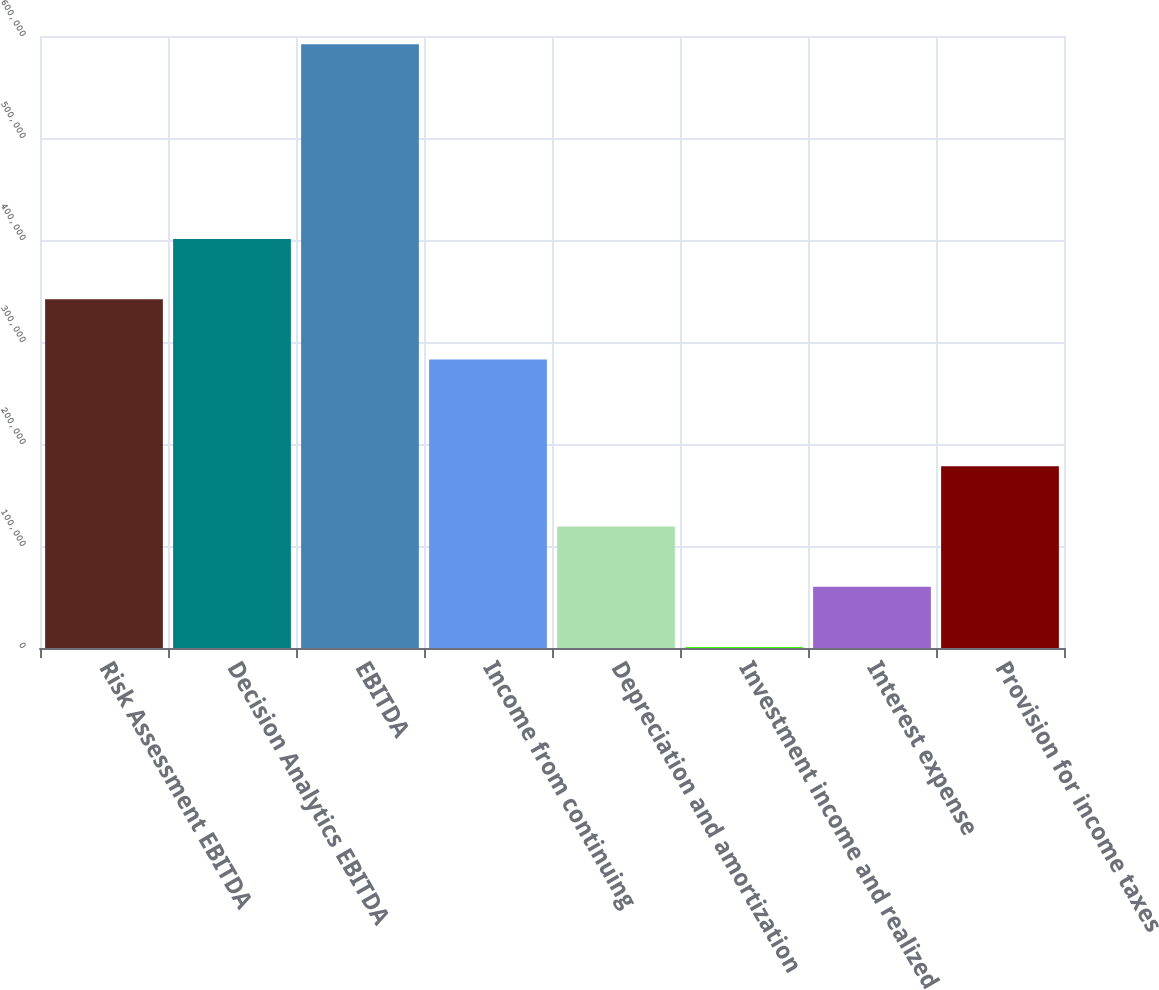<chart> <loc_0><loc_0><loc_500><loc_500><bar_chart><fcel>Risk Assessment EBITDA<fcel>Decision Analytics EBITDA<fcel>EBITDA<fcel>Income from continuing<fcel>Depreciation and amortization<fcel>Investment income and realized<fcel>Interest expense<fcel>Provision for income taxes<nl><fcel>341869<fcel>400981<fcel>592000<fcel>282758<fcel>119110<fcel>887<fcel>59998.3<fcel>178221<nl></chart> 